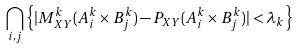Convert formula to latex. <formula><loc_0><loc_0><loc_500><loc_500>\bigcap _ { i , j } \left \{ | M ^ { k } _ { X Y } ( A ^ { k } _ { i } \times B ^ { k } _ { j } ) - P _ { X Y } ( A ^ { k } _ { i } \times B ^ { k } _ { j } ) | < \lambda _ { k } \right \}</formula> 